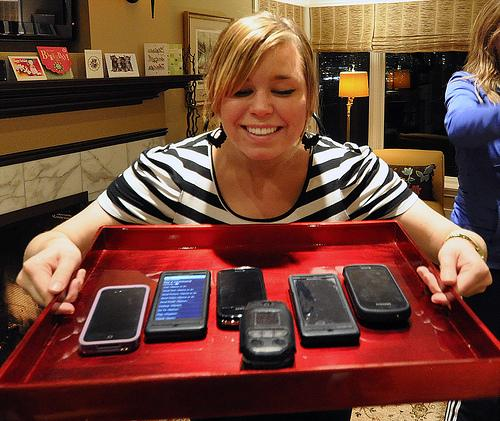Mention an activity the young lady in the image appears to be involved in. The young woman is holding a red tray with various cell phones. What type of phones does the young woman hold on the tray? Mention at least three. A Samsung smartphone, an old flip phone, and an iPhone. Describe the accessories the young lady in the photo is wearing. The young lady is wearing black chandelier earrings, and a watch on her wrist. What's the most striking feature of the rectangular smartphone? The rectangular smartphone has a blue and white display on its screen. Which object in the image is placed near a window and describe its details. A lamp with a yellow shade is positioned in front of a window, having a pole structure. What can you see on the red tray? There are six cell phones, some black and white smartphones, an old flip phone, a Samsung smartphone, and an iPhone. Is there any unusual furniture in the photo? If so, please describe it. Yes, there is a brown chair with a black flower pillow in the image. Name one interesting object in close proximity to the fireplace mantel. Birthday cards are placed above the fireplace mantel. 